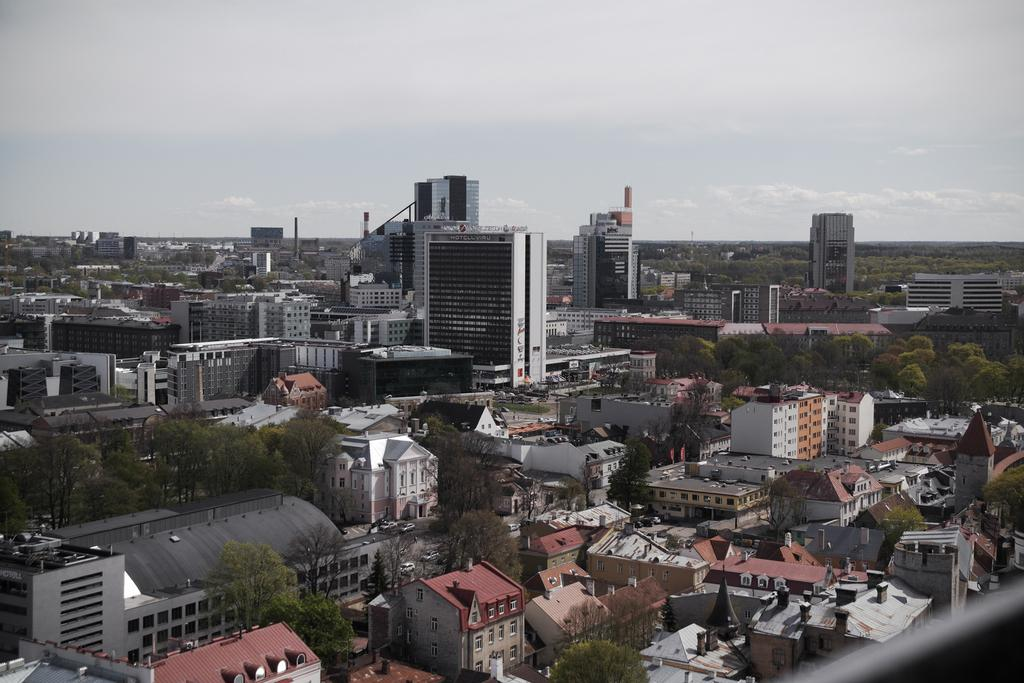What type of structures can be seen in the image? There are buildings in the image. What natural elements are present in the image? There are trees in the image. What architectural features can be observed in the image? There are windows and poles in the image. What is visible in the background of the image? The sky is visible in the background of the image. What atmospheric conditions can be inferred from the image? Clouds are present in the sky, suggesting a partly cloudy day. What type of yarn is being used to create the governor's butter sculpture in the image? There is no yarn, governor, or butter sculpture present in the image. 